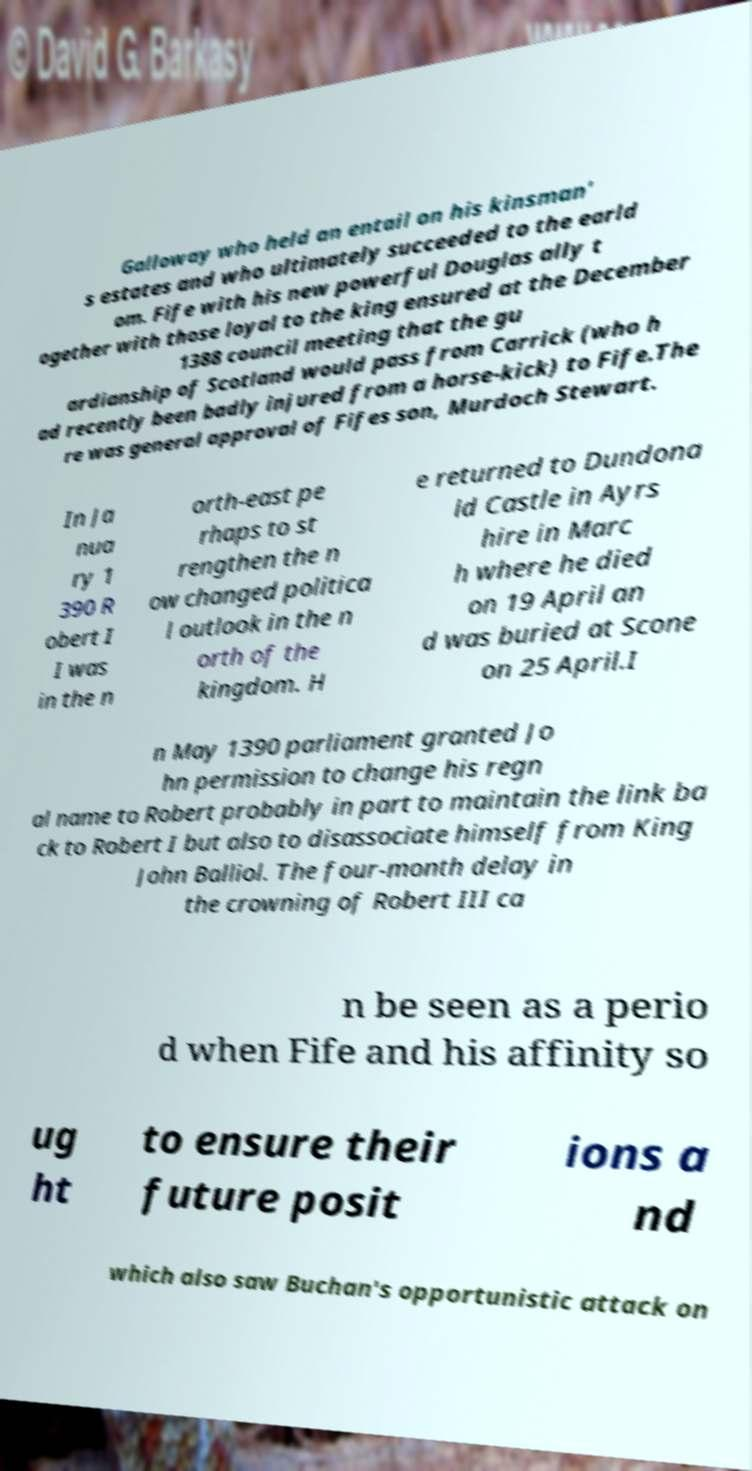Could you extract and type out the text from this image? Galloway who held an entail on his kinsman' s estates and who ultimately succeeded to the earld om. Fife with his new powerful Douglas ally t ogether with those loyal to the king ensured at the December 1388 council meeting that the gu ardianship of Scotland would pass from Carrick (who h ad recently been badly injured from a horse-kick) to Fife.The re was general approval of Fifes son, Murdoch Stewart. In Ja nua ry 1 390 R obert I I was in the n orth-east pe rhaps to st rengthen the n ow changed politica l outlook in the n orth of the kingdom. H e returned to Dundona ld Castle in Ayrs hire in Marc h where he died on 19 April an d was buried at Scone on 25 April.I n May 1390 parliament granted Jo hn permission to change his regn al name to Robert probably in part to maintain the link ba ck to Robert I but also to disassociate himself from King John Balliol. The four-month delay in the crowning of Robert III ca n be seen as a perio d when Fife and his affinity so ug ht to ensure their future posit ions a nd which also saw Buchan's opportunistic attack on 